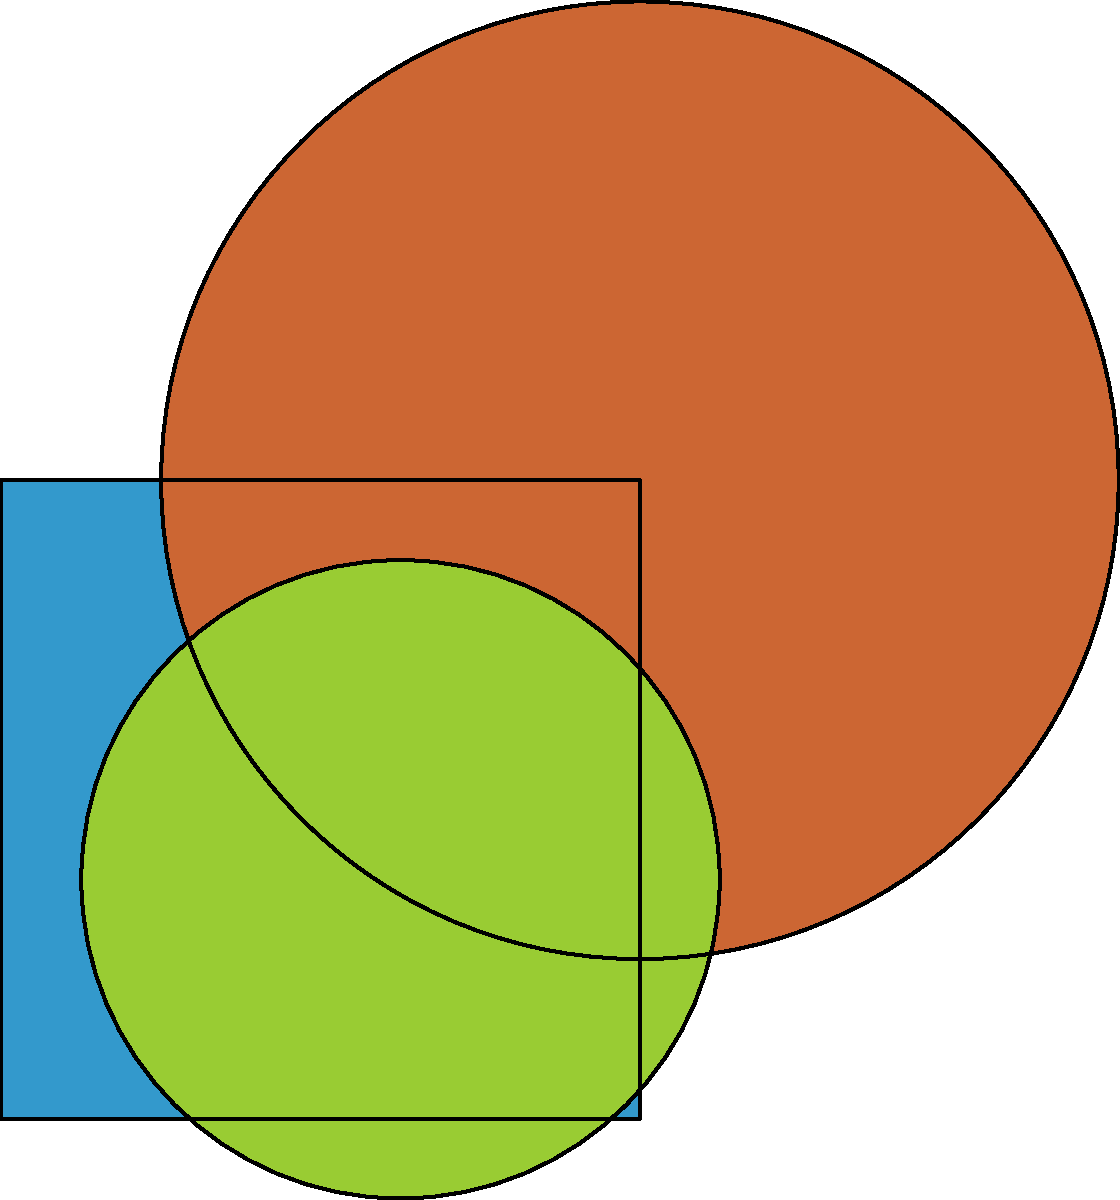As a data analytics software startup, you want to create a unique logo that represents your company's innovative approach. Using the given geometric shapes (square, triangle, and circle), mentally manipulate and combine them to form a cohesive logo. How many distinct ways can you arrange these shapes to create a vertically stacked logo, where each shape appears exactly once and no two shapes overlap? To solve this problem, we need to consider the possible arrangements of the three shapes (square, triangle, and circle) in a vertical stack. Here's a step-by-step approach:

1. We have 3 distinct shapes, and we need to arrange them vertically.

2. This is a permutation problem, as the order matters and we use each shape exactly once.

3. The number of permutations for n distinct objects is given by the formula:

   $n!$ (n factorial)

4. In this case, $n = 3$ (square, triangle, and circle)

5. Therefore, the number of distinct arrangements is:

   $3! = 3 \times 2 \times 1 = 6$

6. Let's list out all possible arrangements:
   - Square, Triangle, Circle
   - Square, Circle, Triangle
   - Triangle, Square, Circle
   - Triangle, Circle, Square
   - Circle, Square, Triangle
   - Circle, Triangle, Square

7. Each of these arrangements represents a unique vertically stacked logo where no two shapes overlap.
Answer: 6 